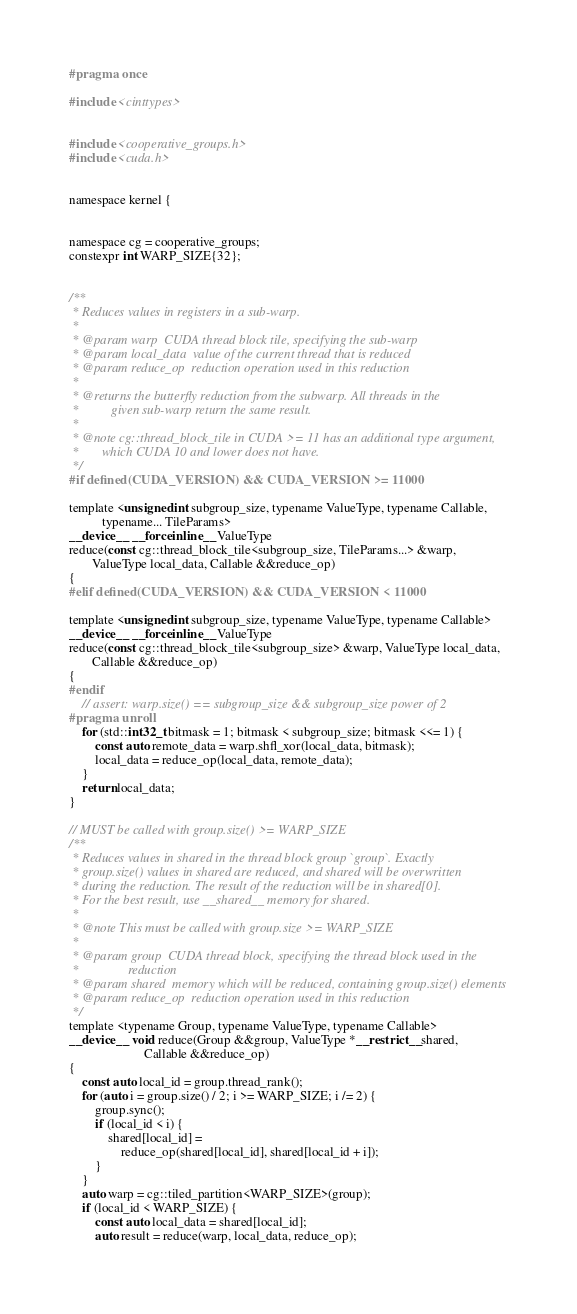Convert code to text. <code><loc_0><loc_0><loc_500><loc_500><_Cuda_>#pragma once

#include <cinttypes>


#include <cooperative_groups.h>
#include <cuda.h>


namespace kernel {


namespace cg = cooperative_groups;
constexpr int WARP_SIZE{32};


/**
 * Reduces values in registers in a sub-warp.
 *
 * @param warp  CUDA thread block tile, specifying the sub-warp
 * @param local_data  value of the current thread that is reduced
 * @param reduce_op  reduction operation used in this reduction
 *
 * @returns the butterfly reduction from the subwarp. All threads in the
 *          given sub-warp return the same result.
 *
 * @note cg::thread_block_tile in CUDA >= 11 has an additional type argument,
 *       which CUDA 10 and lower does not have.
 */
#if defined(CUDA_VERSION) && CUDA_VERSION >= 11000

template <unsigned int subgroup_size, typename ValueType, typename Callable,
          typename... TileParams>
__device__ __forceinline__ ValueType
reduce(const cg::thread_block_tile<subgroup_size, TileParams...> &warp,
       ValueType local_data, Callable &&reduce_op)
{
#elif defined(CUDA_VERSION) && CUDA_VERSION < 11000

template <unsigned int subgroup_size, typename ValueType, typename Callable>
__device__ __forceinline__ ValueType
reduce(const cg::thread_block_tile<subgroup_size> &warp, ValueType local_data,
       Callable &&reduce_op)
{
#endif
    // assert: warp.size() == subgroup_size && subgroup_size power of 2
#pragma unroll
    for (std::int32_t bitmask = 1; bitmask < subgroup_size; bitmask <<= 1) {
        const auto remote_data = warp.shfl_xor(local_data, bitmask);
        local_data = reduce_op(local_data, remote_data);
    }
    return local_data;
}

// MUST be called with group.size() >= WARP_SIZE
/**
 * Reduces values in shared in the thread block group `group`. Exactly
 * group.size() values in shared are reduced, and shared will be overwritten
 * during the reduction. The result of the reduction will be in shared[0].
 * For the best result, use __shared__ memory for shared.
 *
 * @note This must be called with group.size >= WARP_SIZE
 *
 * @param group  CUDA thread block, specifying the thread block used in the
 *               reduction
 * @param shared  memory which will be reduced, containing group.size() elements
 * @param reduce_op  reduction operation used in this reduction
 */
template <typename Group, typename ValueType, typename Callable>
__device__ void reduce(Group &&group, ValueType *__restrict__ shared,
                       Callable &&reduce_op)
{
    const auto local_id = group.thread_rank();
    for (auto i = group.size() / 2; i >= WARP_SIZE; i /= 2) {
        group.sync();
        if (local_id < i) {
            shared[local_id] =
                reduce_op(shared[local_id], shared[local_id + i]);
        }
    }
    auto warp = cg::tiled_partition<WARP_SIZE>(group);
    if (local_id < WARP_SIZE) {
        const auto local_data = shared[local_id];
        auto result = reduce(warp, local_data, reduce_op);</code> 